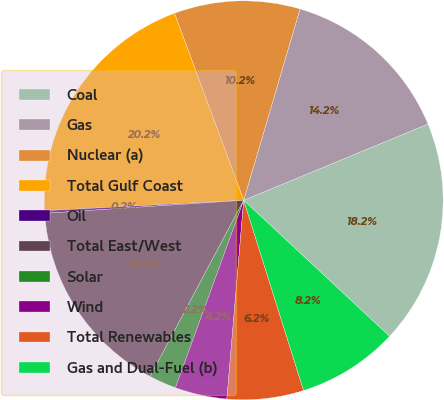<chart> <loc_0><loc_0><loc_500><loc_500><pie_chart><fcel>Coal<fcel>Gas<fcel>Nuclear (a)<fcel>Total Gulf Coast<fcel>Oil<fcel>Total East/West<fcel>Solar<fcel>Wind<fcel>Total Renewables<fcel>Gas and Dual-Fuel (b)<nl><fcel>18.19%<fcel>14.2%<fcel>10.2%<fcel>20.19%<fcel>0.21%<fcel>16.19%<fcel>2.21%<fcel>4.21%<fcel>6.2%<fcel>8.2%<nl></chart> 